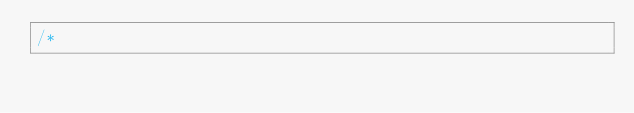<code> <loc_0><loc_0><loc_500><loc_500><_Scala_>/*</code> 